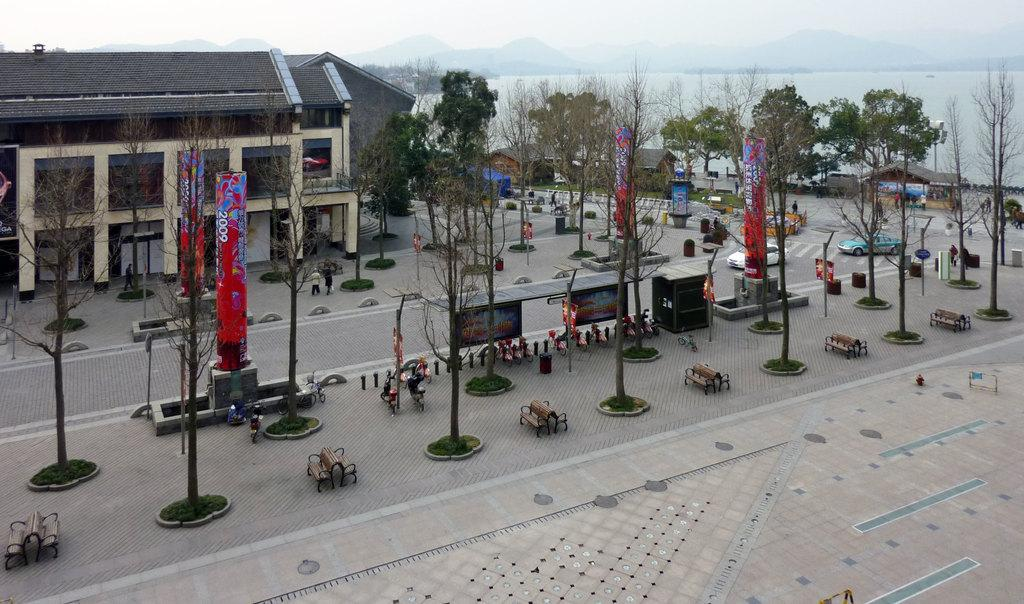What type of pathway is visible in the image? There is a lane in the image in the image. What can be seen alongside the lane? Trees are present along the lane. What type of seating is available in the image? There are benches in the image. What mode of transportation can be seen in the image? Cars are visible in the image. What else is present in the image besides the lane, trees, benches, and cars? There are objects and people in the image. What can be seen in the background of the image? There is a building, the sky, water, and mountains visible in the background of the image. What type of cloth is being used to cover the yam during the feast in the image? There is no cloth, yam, or feast present in the image. 